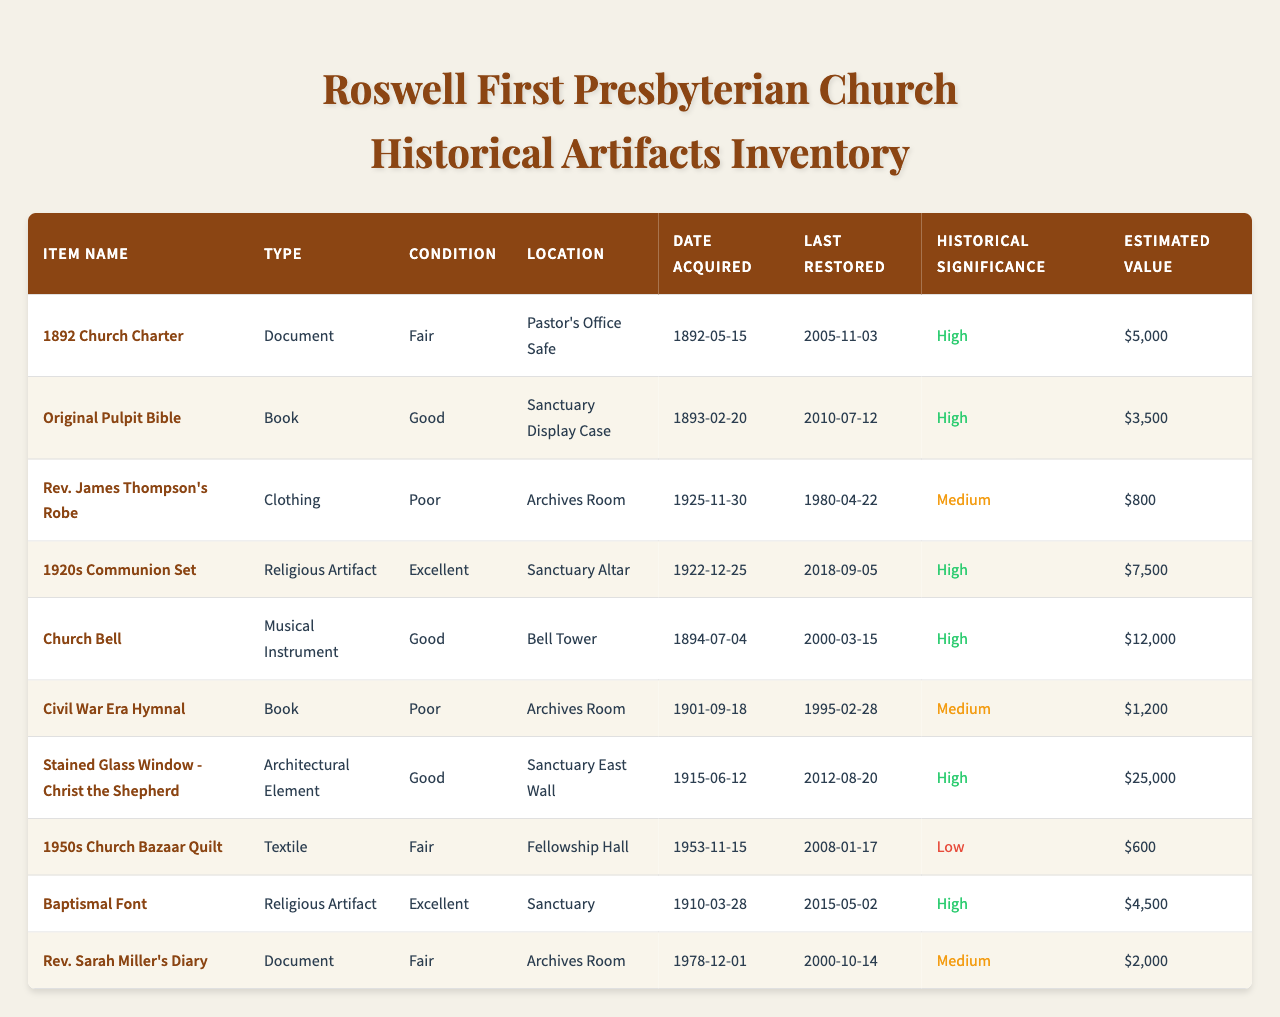What is the condition of the Original Pulpit Bible? The condition of the Original Pulpit Bible is listed in the table as "Good."
Answer: Good Where is the Church Bell located? The table indicates that the Church Bell is located in the "Bell Tower."
Answer: Bell Tower Which item has the highest estimated value? To find the item with the highest estimated value, I can compare the estimated values listed in the table. The Stained Glass Window - Christ the Shepherd has an estimated value of $25,000, which is the highest.
Answer: Stained Glass Window - Christ the Shepherd How many artifacts are in poor condition? By reviewing the condition column in the table, I see that there are 3 items classified as "Poor." They are Rev. James Thompson's Robe, Civil War Era Hymnal, and the Original Pulpit Bible.
Answer: 3 What was the last restoration date of the 1920s Communion Set? The last restoration date for the 1920s Communion Set is found in the table, which states it was last restored on September 5, 2018.
Answer: September 5, 2018 Is the 1892 Church Charter considered to have high historical significance? The table shows that the 1892 Church Charter has a historical significance labeled as "High." Therefore, it does have high historical significance.
Answer: Yes What is the difference in estimated value between the Church Bell and the Baptismal Font? The estimated value of the Church Bell is $12,000, and that of the Baptismal Font is $4,500. Subtracting these values gives $12,000 - $4,500 = $7,500.
Answer: $7,500 Which type of artifacts are most likely in the Archives Room? There are 3 items located in the Archives Room: Rev. James Thompson's Robe, Civil War Era Hymnal, and Rev. Sarah Miller's Diary. This suggests that clothing and documents are the main types found there.
Answer: Clothing and Documents On what date was the Rev. Sarah Miller's Diary acquired? According to the table, the Rev. Sarah Miller's Diary was acquired on December 1, 1978.
Answer: December 1, 1978 How does the historical significance of the 1950s Church Bazaar Quilt compare to other items? The 1950s Church Bazaar Quilt has a historical significance categorized as "Low," which is lower compared to other items like the Stained Glass Window and Church Bell that are both marked as "High."
Answer: Low 